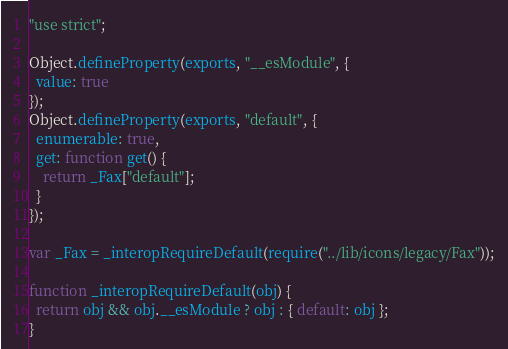Convert code to text. <code><loc_0><loc_0><loc_500><loc_500><_JavaScript_>"use strict";

Object.defineProperty(exports, "__esModule", {
  value: true
});
Object.defineProperty(exports, "default", {
  enumerable: true,
  get: function get() {
    return _Fax["default"];
  }
});

var _Fax = _interopRequireDefault(require("../lib/icons/legacy/Fax"));

function _interopRequireDefault(obj) {
  return obj && obj.__esModule ? obj : { default: obj };
}
</code> 